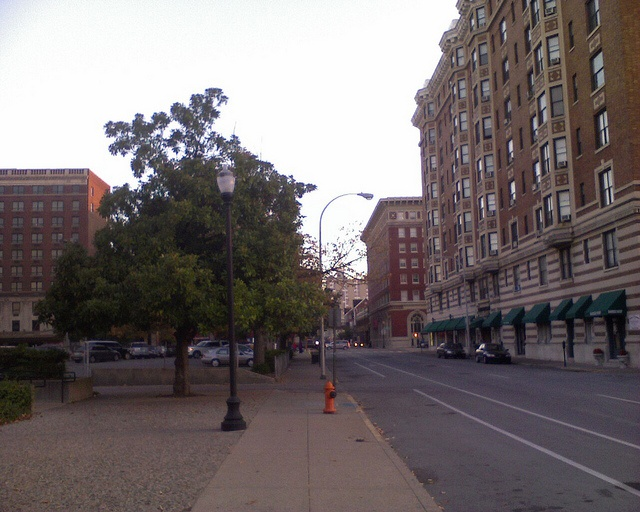Describe the objects in this image and their specific colors. I can see car in lavender, black, gray, and darkgray tones, car in lavender, gray, and black tones, car in lavender, black, and gray tones, car in lavender, black, and gray tones, and car in lavender and black tones in this image. 